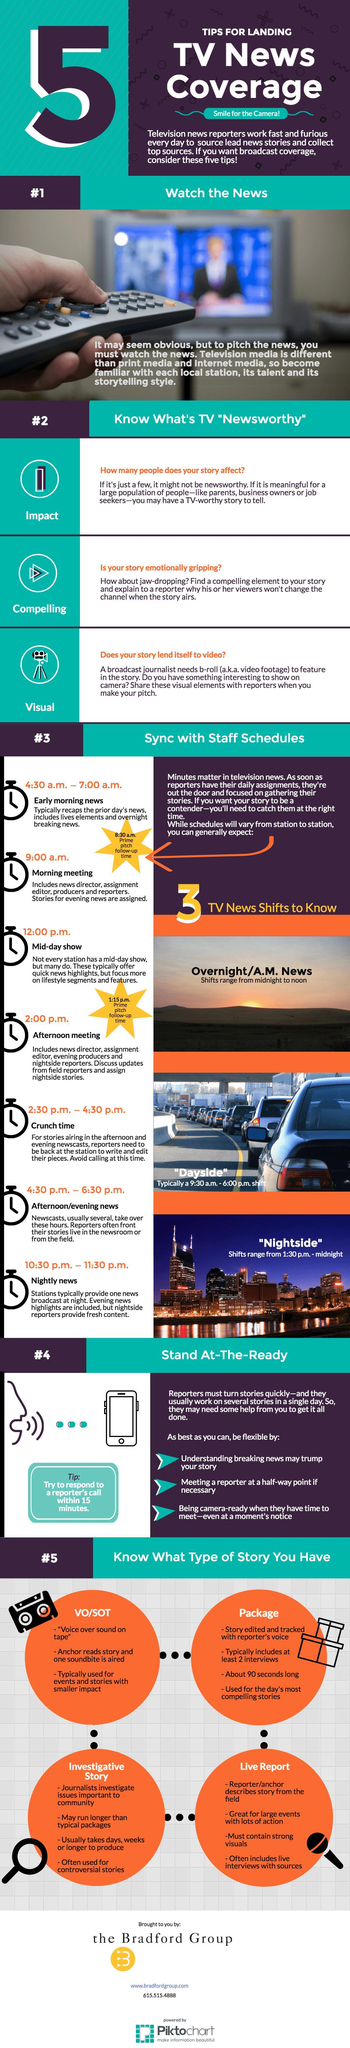Which are three TV news shifts ?
Answer the question with a short phrase. Overnight/ A.M. News, Dayside, Nightside What are the Prime pitch follow-up times ? 8.30 am, 1:15 pm 